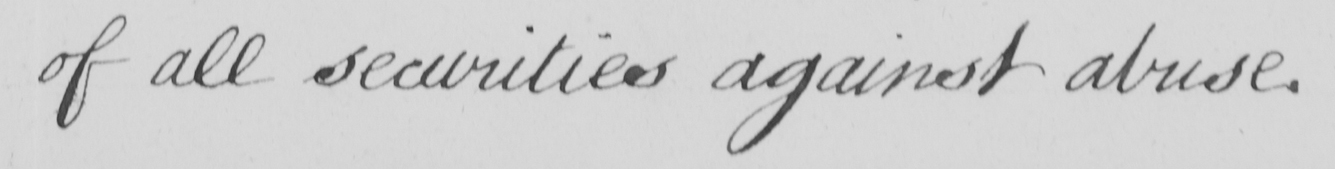What is written in this line of handwriting? of all securities against abuse . 